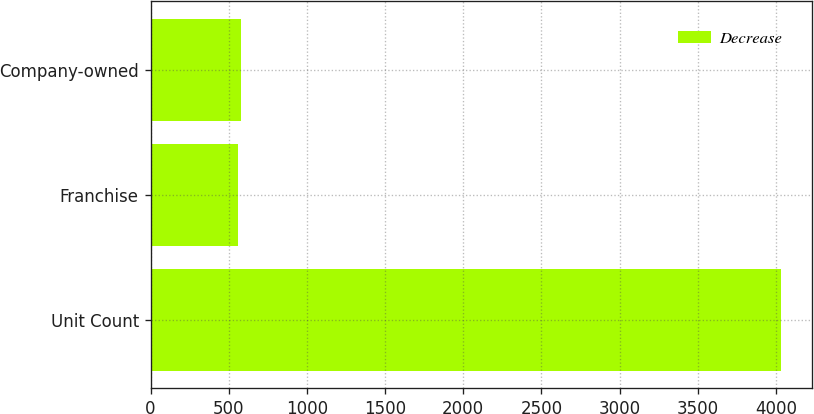Convert chart. <chart><loc_0><loc_0><loc_500><loc_500><stacked_bar_chart><ecel><fcel>Unit Count<fcel>Franchise<fcel>Company-owned<nl><fcel>nan<fcel>2016<fcel>553<fcel>553<nl><fcel>Decrease<fcel>2016<fcel>4<fcel>27<nl></chart> 